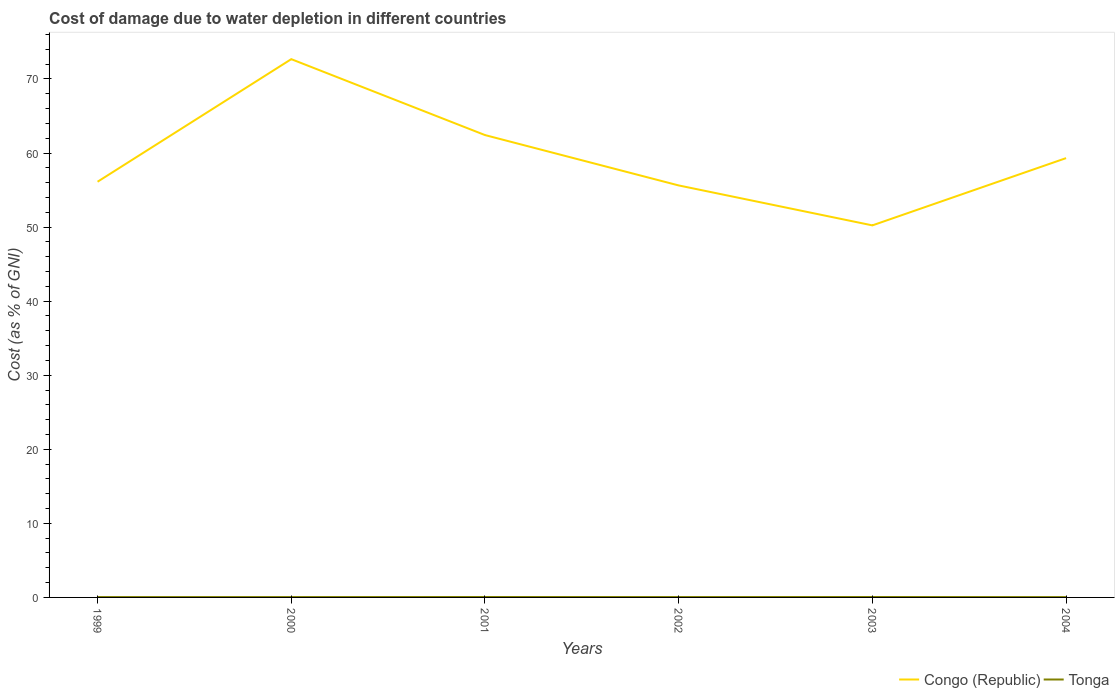How many different coloured lines are there?
Your response must be concise. 2. Does the line corresponding to Congo (Republic) intersect with the line corresponding to Tonga?
Your answer should be very brief. No. Is the number of lines equal to the number of legend labels?
Your response must be concise. Yes. Across all years, what is the maximum cost of damage caused due to water depletion in Tonga?
Offer a very short reply. 0.04. What is the total cost of damage caused due to water depletion in Congo (Republic) in the graph?
Make the answer very short. 5.89. What is the difference between the highest and the second highest cost of damage caused due to water depletion in Tonga?
Your answer should be compact. 0.01. What is the difference between the highest and the lowest cost of damage caused due to water depletion in Tonga?
Offer a very short reply. 2. Is the cost of damage caused due to water depletion in Congo (Republic) strictly greater than the cost of damage caused due to water depletion in Tonga over the years?
Make the answer very short. No. How many lines are there?
Offer a terse response. 2. Are the values on the major ticks of Y-axis written in scientific E-notation?
Offer a terse response. No. Where does the legend appear in the graph?
Your answer should be very brief. Bottom right. How many legend labels are there?
Your response must be concise. 2. What is the title of the graph?
Offer a terse response. Cost of damage due to water depletion in different countries. Does "Faeroe Islands" appear as one of the legend labels in the graph?
Your answer should be compact. No. What is the label or title of the X-axis?
Provide a succinct answer. Years. What is the label or title of the Y-axis?
Provide a succinct answer. Cost (as % of GNI). What is the Cost (as % of GNI) of Congo (Republic) in 1999?
Provide a succinct answer. 56.12. What is the Cost (as % of GNI) in Tonga in 1999?
Provide a short and direct response. 0.05. What is the Cost (as % of GNI) of Congo (Republic) in 2000?
Give a very brief answer. 72.68. What is the Cost (as % of GNI) in Tonga in 2000?
Make the answer very short. 0.05. What is the Cost (as % of GNI) of Congo (Republic) in 2001?
Your answer should be compact. 62.43. What is the Cost (as % of GNI) in Tonga in 2001?
Offer a very short reply. 0.06. What is the Cost (as % of GNI) in Congo (Republic) in 2002?
Your answer should be compact. 55.63. What is the Cost (as % of GNI) in Tonga in 2002?
Your answer should be compact. 0.05. What is the Cost (as % of GNI) in Congo (Republic) in 2003?
Provide a short and direct response. 50.23. What is the Cost (as % of GNI) of Tonga in 2003?
Your answer should be very brief. 0.06. What is the Cost (as % of GNI) in Congo (Republic) in 2004?
Your answer should be compact. 59.31. What is the Cost (as % of GNI) in Tonga in 2004?
Offer a terse response. 0.04. Across all years, what is the maximum Cost (as % of GNI) in Congo (Republic)?
Offer a terse response. 72.68. Across all years, what is the maximum Cost (as % of GNI) of Tonga?
Offer a terse response. 0.06. Across all years, what is the minimum Cost (as % of GNI) in Congo (Republic)?
Your answer should be very brief. 50.23. Across all years, what is the minimum Cost (as % of GNI) of Tonga?
Ensure brevity in your answer.  0.04. What is the total Cost (as % of GNI) of Congo (Republic) in the graph?
Offer a very short reply. 356.4. What is the total Cost (as % of GNI) in Tonga in the graph?
Give a very brief answer. 0.31. What is the difference between the Cost (as % of GNI) in Congo (Republic) in 1999 and that in 2000?
Offer a very short reply. -16.55. What is the difference between the Cost (as % of GNI) in Tonga in 1999 and that in 2000?
Provide a short and direct response. 0. What is the difference between the Cost (as % of GNI) of Congo (Republic) in 1999 and that in 2001?
Your response must be concise. -6.3. What is the difference between the Cost (as % of GNI) in Tonga in 1999 and that in 2001?
Keep it short and to the point. -0.01. What is the difference between the Cost (as % of GNI) of Congo (Republic) in 1999 and that in 2002?
Offer a terse response. 0.5. What is the difference between the Cost (as % of GNI) of Tonga in 1999 and that in 2002?
Your response must be concise. -0. What is the difference between the Cost (as % of GNI) in Congo (Republic) in 1999 and that in 2003?
Offer a terse response. 5.89. What is the difference between the Cost (as % of GNI) of Tonga in 1999 and that in 2003?
Ensure brevity in your answer.  -0.01. What is the difference between the Cost (as % of GNI) in Congo (Republic) in 1999 and that in 2004?
Offer a very short reply. -3.19. What is the difference between the Cost (as % of GNI) in Tonga in 1999 and that in 2004?
Provide a short and direct response. 0.01. What is the difference between the Cost (as % of GNI) in Congo (Republic) in 2000 and that in 2001?
Your answer should be compact. 10.25. What is the difference between the Cost (as % of GNI) in Tonga in 2000 and that in 2001?
Offer a very short reply. -0.01. What is the difference between the Cost (as % of GNI) in Congo (Republic) in 2000 and that in 2002?
Keep it short and to the point. 17.05. What is the difference between the Cost (as % of GNI) in Tonga in 2000 and that in 2002?
Ensure brevity in your answer.  -0. What is the difference between the Cost (as % of GNI) in Congo (Republic) in 2000 and that in 2003?
Your response must be concise. 22.44. What is the difference between the Cost (as % of GNI) in Tonga in 2000 and that in 2003?
Offer a terse response. -0.01. What is the difference between the Cost (as % of GNI) of Congo (Republic) in 2000 and that in 2004?
Your answer should be very brief. 13.36. What is the difference between the Cost (as % of GNI) of Tonga in 2000 and that in 2004?
Provide a succinct answer. 0. What is the difference between the Cost (as % of GNI) in Congo (Republic) in 2001 and that in 2002?
Ensure brevity in your answer.  6.8. What is the difference between the Cost (as % of GNI) of Tonga in 2001 and that in 2002?
Keep it short and to the point. 0.01. What is the difference between the Cost (as % of GNI) in Congo (Republic) in 2001 and that in 2003?
Ensure brevity in your answer.  12.19. What is the difference between the Cost (as % of GNI) in Tonga in 2001 and that in 2003?
Give a very brief answer. -0. What is the difference between the Cost (as % of GNI) of Congo (Republic) in 2001 and that in 2004?
Offer a very short reply. 3.11. What is the difference between the Cost (as % of GNI) of Tonga in 2001 and that in 2004?
Give a very brief answer. 0.01. What is the difference between the Cost (as % of GNI) in Congo (Republic) in 2002 and that in 2003?
Provide a short and direct response. 5.39. What is the difference between the Cost (as % of GNI) of Tonga in 2002 and that in 2003?
Ensure brevity in your answer.  -0.01. What is the difference between the Cost (as % of GNI) of Congo (Republic) in 2002 and that in 2004?
Offer a very short reply. -3.69. What is the difference between the Cost (as % of GNI) of Tonga in 2002 and that in 2004?
Offer a terse response. 0.01. What is the difference between the Cost (as % of GNI) of Congo (Republic) in 2003 and that in 2004?
Your answer should be very brief. -9.08. What is the difference between the Cost (as % of GNI) in Tonga in 2003 and that in 2004?
Provide a succinct answer. 0.01. What is the difference between the Cost (as % of GNI) in Congo (Republic) in 1999 and the Cost (as % of GNI) in Tonga in 2000?
Ensure brevity in your answer.  56.08. What is the difference between the Cost (as % of GNI) of Congo (Republic) in 1999 and the Cost (as % of GNI) of Tonga in 2001?
Give a very brief answer. 56.07. What is the difference between the Cost (as % of GNI) of Congo (Republic) in 1999 and the Cost (as % of GNI) of Tonga in 2002?
Offer a very short reply. 56.07. What is the difference between the Cost (as % of GNI) of Congo (Republic) in 1999 and the Cost (as % of GNI) of Tonga in 2003?
Your answer should be compact. 56.07. What is the difference between the Cost (as % of GNI) in Congo (Republic) in 1999 and the Cost (as % of GNI) in Tonga in 2004?
Ensure brevity in your answer.  56.08. What is the difference between the Cost (as % of GNI) in Congo (Republic) in 2000 and the Cost (as % of GNI) in Tonga in 2001?
Provide a succinct answer. 72.62. What is the difference between the Cost (as % of GNI) of Congo (Republic) in 2000 and the Cost (as % of GNI) of Tonga in 2002?
Provide a succinct answer. 72.63. What is the difference between the Cost (as % of GNI) of Congo (Republic) in 2000 and the Cost (as % of GNI) of Tonga in 2003?
Give a very brief answer. 72.62. What is the difference between the Cost (as % of GNI) of Congo (Republic) in 2000 and the Cost (as % of GNI) of Tonga in 2004?
Offer a terse response. 72.63. What is the difference between the Cost (as % of GNI) in Congo (Republic) in 2001 and the Cost (as % of GNI) in Tonga in 2002?
Give a very brief answer. 62.38. What is the difference between the Cost (as % of GNI) in Congo (Republic) in 2001 and the Cost (as % of GNI) in Tonga in 2003?
Offer a very short reply. 62.37. What is the difference between the Cost (as % of GNI) in Congo (Republic) in 2001 and the Cost (as % of GNI) in Tonga in 2004?
Your answer should be compact. 62.38. What is the difference between the Cost (as % of GNI) in Congo (Republic) in 2002 and the Cost (as % of GNI) in Tonga in 2003?
Your response must be concise. 55.57. What is the difference between the Cost (as % of GNI) of Congo (Republic) in 2002 and the Cost (as % of GNI) of Tonga in 2004?
Your answer should be compact. 55.58. What is the difference between the Cost (as % of GNI) in Congo (Republic) in 2003 and the Cost (as % of GNI) in Tonga in 2004?
Your response must be concise. 50.19. What is the average Cost (as % of GNI) in Congo (Republic) per year?
Give a very brief answer. 59.4. What is the average Cost (as % of GNI) of Tonga per year?
Your response must be concise. 0.05. In the year 1999, what is the difference between the Cost (as % of GNI) in Congo (Republic) and Cost (as % of GNI) in Tonga?
Offer a terse response. 56.08. In the year 2000, what is the difference between the Cost (as % of GNI) of Congo (Republic) and Cost (as % of GNI) of Tonga?
Give a very brief answer. 72.63. In the year 2001, what is the difference between the Cost (as % of GNI) in Congo (Republic) and Cost (as % of GNI) in Tonga?
Keep it short and to the point. 62.37. In the year 2002, what is the difference between the Cost (as % of GNI) in Congo (Republic) and Cost (as % of GNI) in Tonga?
Your answer should be compact. 55.58. In the year 2003, what is the difference between the Cost (as % of GNI) in Congo (Republic) and Cost (as % of GNI) in Tonga?
Make the answer very short. 50.17. In the year 2004, what is the difference between the Cost (as % of GNI) in Congo (Republic) and Cost (as % of GNI) in Tonga?
Make the answer very short. 59.27. What is the ratio of the Cost (as % of GNI) in Congo (Republic) in 1999 to that in 2000?
Give a very brief answer. 0.77. What is the ratio of the Cost (as % of GNI) of Tonga in 1999 to that in 2000?
Offer a very short reply. 1.01. What is the ratio of the Cost (as % of GNI) of Congo (Republic) in 1999 to that in 2001?
Provide a short and direct response. 0.9. What is the ratio of the Cost (as % of GNI) in Tonga in 1999 to that in 2001?
Provide a short and direct response. 0.88. What is the ratio of the Cost (as % of GNI) in Tonga in 1999 to that in 2002?
Your answer should be compact. 0.99. What is the ratio of the Cost (as % of GNI) of Congo (Republic) in 1999 to that in 2003?
Give a very brief answer. 1.12. What is the ratio of the Cost (as % of GNI) of Tonga in 1999 to that in 2003?
Provide a short and direct response. 0.85. What is the ratio of the Cost (as % of GNI) of Congo (Republic) in 1999 to that in 2004?
Make the answer very short. 0.95. What is the ratio of the Cost (as % of GNI) of Tonga in 1999 to that in 2004?
Give a very brief answer. 1.11. What is the ratio of the Cost (as % of GNI) in Congo (Republic) in 2000 to that in 2001?
Provide a short and direct response. 1.16. What is the ratio of the Cost (as % of GNI) in Tonga in 2000 to that in 2001?
Your response must be concise. 0.87. What is the ratio of the Cost (as % of GNI) in Congo (Republic) in 2000 to that in 2002?
Keep it short and to the point. 1.31. What is the ratio of the Cost (as % of GNI) in Tonga in 2000 to that in 2002?
Provide a short and direct response. 0.98. What is the ratio of the Cost (as % of GNI) of Congo (Republic) in 2000 to that in 2003?
Offer a terse response. 1.45. What is the ratio of the Cost (as % of GNI) in Tonga in 2000 to that in 2003?
Ensure brevity in your answer.  0.85. What is the ratio of the Cost (as % of GNI) in Congo (Republic) in 2000 to that in 2004?
Provide a short and direct response. 1.23. What is the ratio of the Cost (as % of GNI) of Tonga in 2000 to that in 2004?
Your answer should be very brief. 1.1. What is the ratio of the Cost (as % of GNI) of Congo (Republic) in 2001 to that in 2002?
Provide a short and direct response. 1.12. What is the ratio of the Cost (as % of GNI) of Tonga in 2001 to that in 2002?
Keep it short and to the point. 1.12. What is the ratio of the Cost (as % of GNI) of Congo (Republic) in 2001 to that in 2003?
Your response must be concise. 1.24. What is the ratio of the Cost (as % of GNI) in Tonga in 2001 to that in 2003?
Make the answer very short. 0.98. What is the ratio of the Cost (as % of GNI) of Congo (Republic) in 2001 to that in 2004?
Provide a succinct answer. 1.05. What is the ratio of the Cost (as % of GNI) of Tonga in 2001 to that in 2004?
Ensure brevity in your answer.  1.27. What is the ratio of the Cost (as % of GNI) of Congo (Republic) in 2002 to that in 2003?
Your answer should be compact. 1.11. What is the ratio of the Cost (as % of GNI) in Tonga in 2002 to that in 2003?
Give a very brief answer. 0.87. What is the ratio of the Cost (as % of GNI) of Congo (Republic) in 2002 to that in 2004?
Your answer should be very brief. 0.94. What is the ratio of the Cost (as % of GNI) of Tonga in 2002 to that in 2004?
Your answer should be very brief. 1.13. What is the ratio of the Cost (as % of GNI) in Congo (Republic) in 2003 to that in 2004?
Offer a very short reply. 0.85. What is the ratio of the Cost (as % of GNI) of Tonga in 2003 to that in 2004?
Your answer should be very brief. 1.3. What is the difference between the highest and the second highest Cost (as % of GNI) of Congo (Republic)?
Your response must be concise. 10.25. What is the difference between the highest and the second highest Cost (as % of GNI) in Tonga?
Make the answer very short. 0. What is the difference between the highest and the lowest Cost (as % of GNI) of Congo (Republic)?
Your answer should be compact. 22.44. What is the difference between the highest and the lowest Cost (as % of GNI) in Tonga?
Provide a succinct answer. 0.01. 